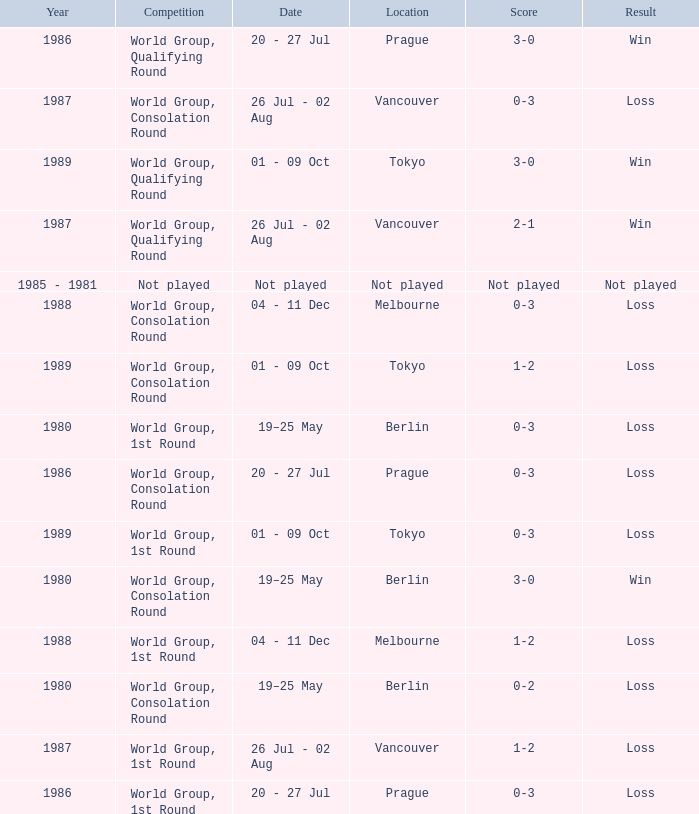What is the competition in tokyo with the result loss? World Group, 1st Round, World Group, Consolation Round. 